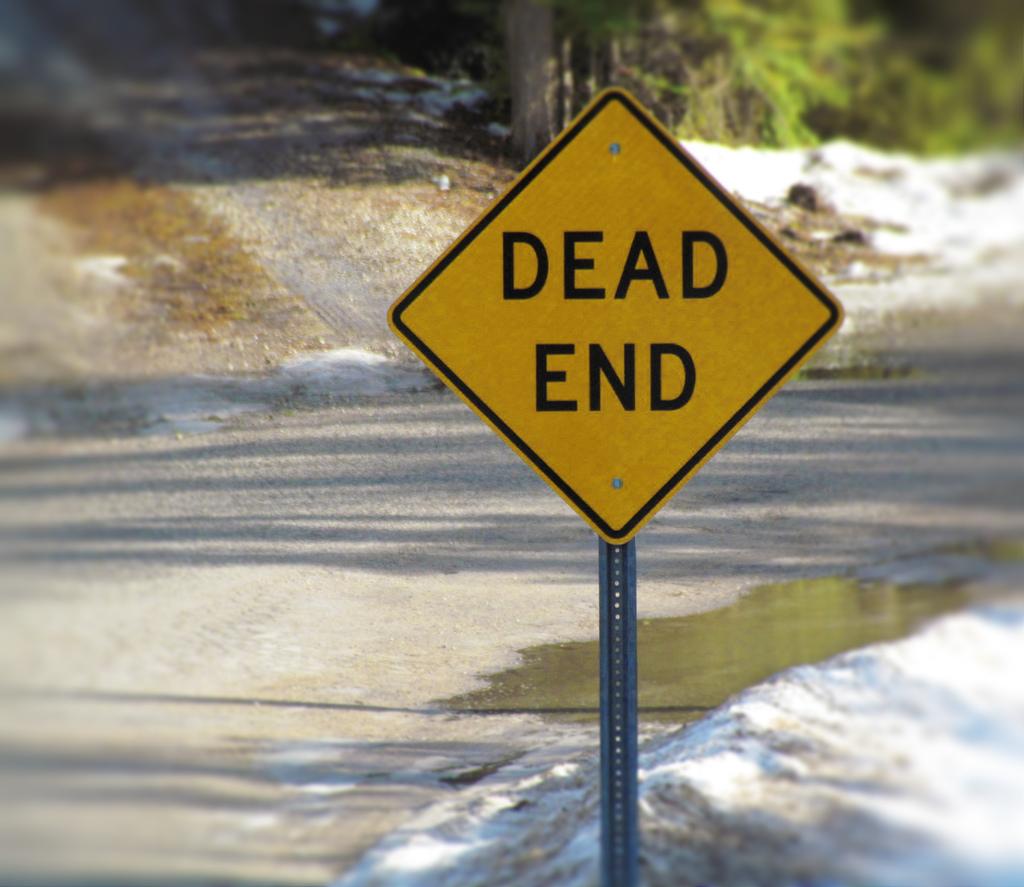What kind of end is it?
Give a very brief answer. Dead. 